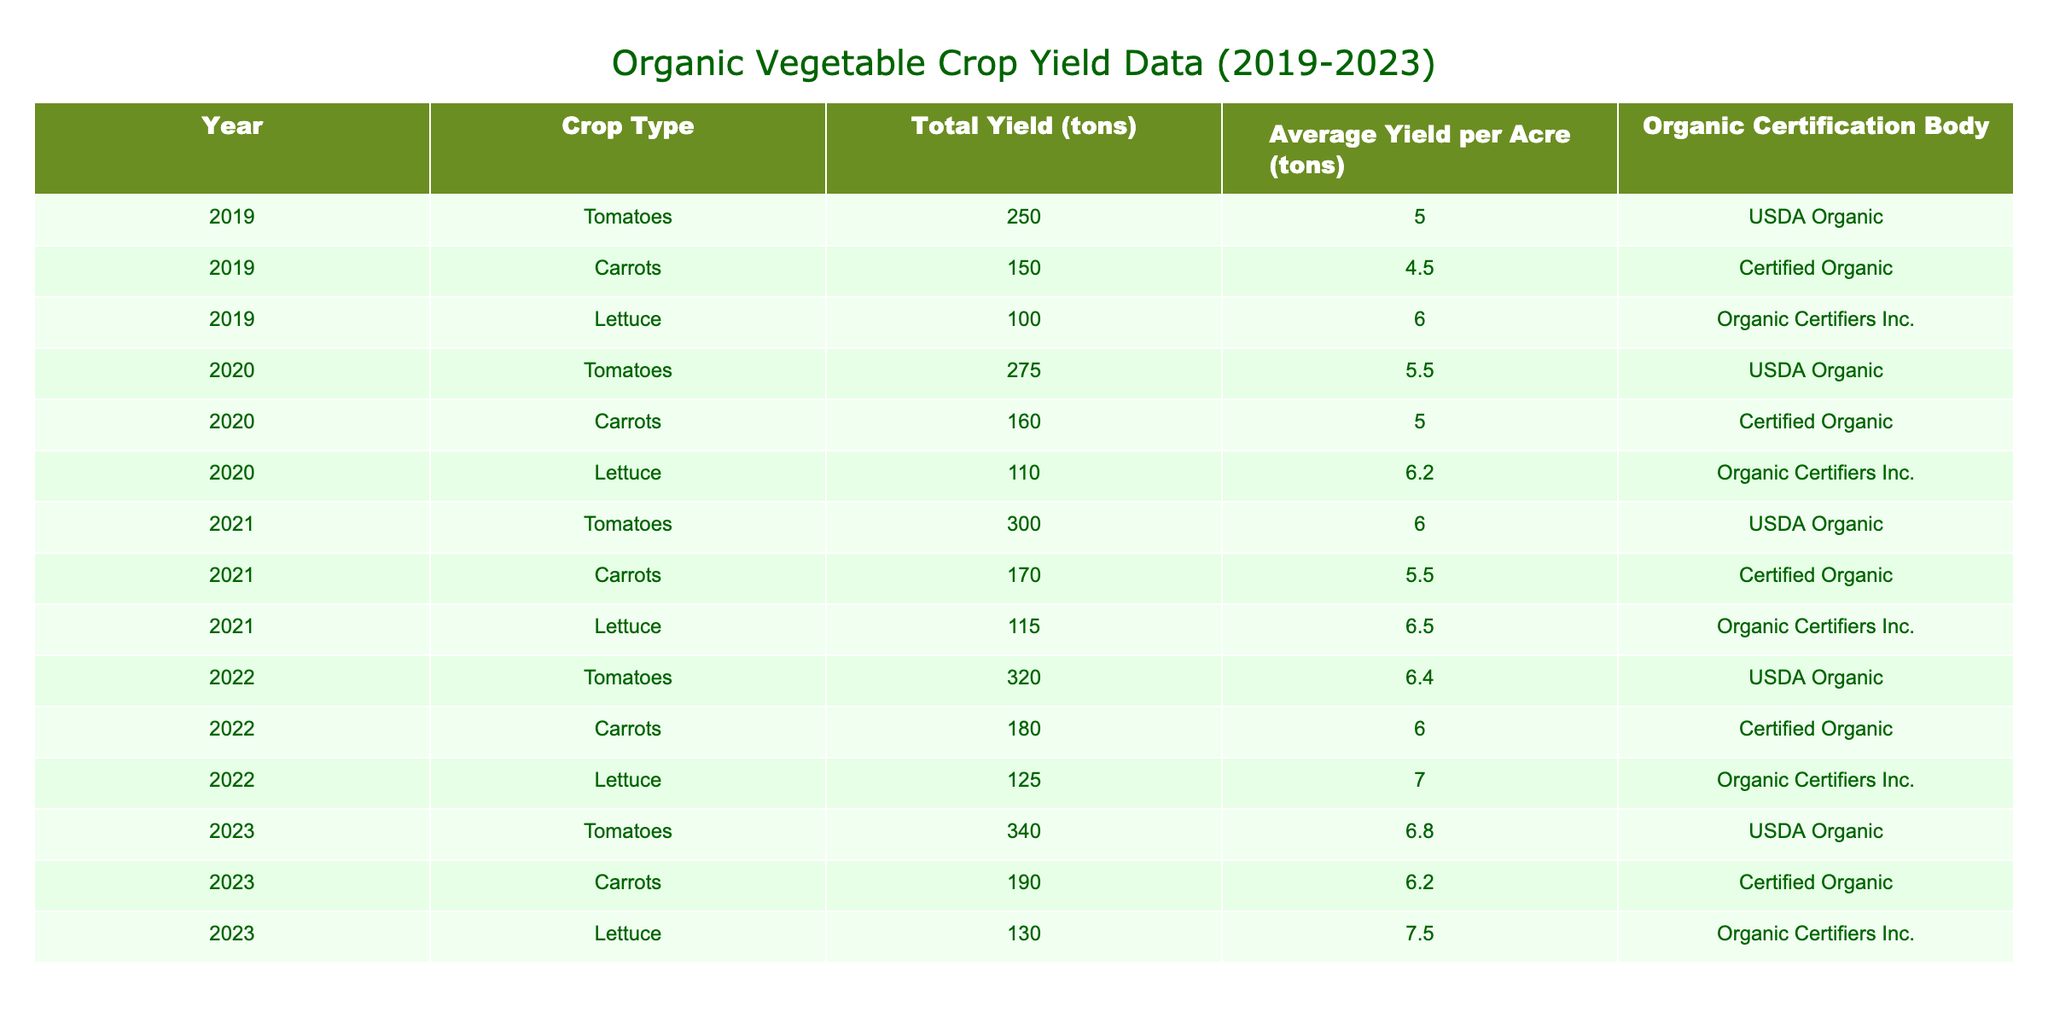What was the total yield of carrots in 2022? In 2022, the row corresponding to carrots shows a total yield of 180 tons. I can directly retrieve this value from the table without any calculations.
Answer: 180 tons What was the average yield per acre for lettuce in 2023? In 2023, the average yield per acre for lettuce is listed as 7.5 tons. This information can be directly found in the table under the respective column for lettuce and year 2023.
Answer: 7.5 tons How many tons of tomatoes were produced from 2019 to 2023 in total? To find the total yield of tomatoes, I add the yields from each year: 250 + 275 + 300 + 320 + 340 = 1485 tons. So, the sum of these yields gives the total production for tomatoes over those years.
Answer: 1485 tons Did the average yield per acre for organic carrots increase from 2021 to 2022? In 2021, the average yield per acre for carrots was 5.5 tons, while in 2022, it was 6.0 tons. Since 6.0 is greater than 5.5, it confirms that there was an increase.
Answer: Yes Which crop type had the highest average yield per acre in 2022? To find this, I will compare the average yields for each crop in 2022. The values for that year are: tomatoes (6.4), carrots (6.0), and lettuce (7.0). Since 7.0 is the highest of these values, lettuce had the highest average yield per acre in 2022.
Answer: Lettuce What was the difference in total yield of tomatoes from 2020 to 2023? I first find the total yield for tomatoes for these years from the table: in 2020 it was 275 tons and in 2023 it was 340 tons. To calculate the difference, I subtract the earlier yield from the later yield: 340 - 275 = 65 tons. Thus, the difference in yield is 65 tons.
Answer: 65 tons Was the organic certification body for carrots consistent over the five years? The certification body listed for carrots was "Certified Organic" for 2019, 2020, 2021, 2022, and 2023. Since it remains the same for every year, the answer is yes.
Answer: Yes What was the average yield per acre for all crops combined in 2021? To find this, I first gather the average yields for each crop in 2021, which were: tomatoes (6.0), carrots (5.5), and lettuce (6.5). I then calculate the average: (6.0 + 5.5 + 6.5) / 3 = 6.0 tons per acre. Thus, the average yield per acre across all crops for 2021 is 6.0 tons.
Answer: 6.0 tons In which year did the total yield of lettuce first exceed 100 tons? Looking through the data, lettuce had a total yield of 100 tons in 2019, and the values for 2020, 2021, and 2022 were 110, 115, and 125 tons respectively. Since 2020 is the first year that exceeded 100 tons, that is my answer.
Answer: 2020 